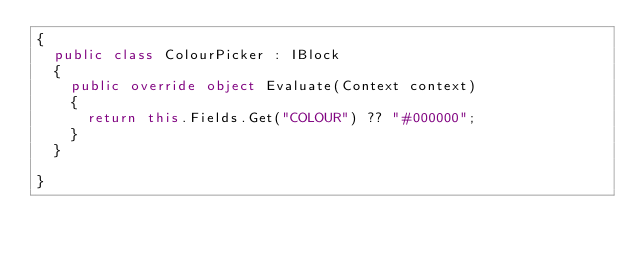Convert code to text. <code><loc_0><loc_0><loc_500><loc_500><_C#_>{
  public class ColourPicker : IBlock
  {
    public override object Evaluate(Context context)
    {
      return this.Fields.Get("COLOUR") ?? "#000000";
    }
  }

}</code> 